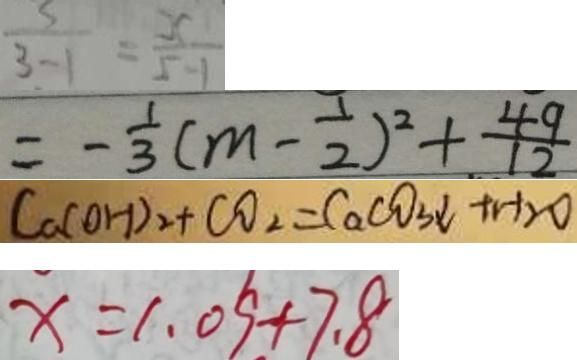Convert formula to latex. <formula><loc_0><loc_0><loc_500><loc_500>\frac { 5 } { 3 - 1 } = \frac { x } { 5 - 1 } 
 = - \frac { 1 } { 3 } ( m - \frac { 1 } { 2 } ) ^ { 2 } + \frac { 4 9 } { 1 2 } 
 C a ( O H ) _ { 2 } + C O _ { 2 } = C a C O _ { 3 } \downarrow + H _ { 2 } O 
 x = 1 . 0 9 + 7 . 8</formula> 